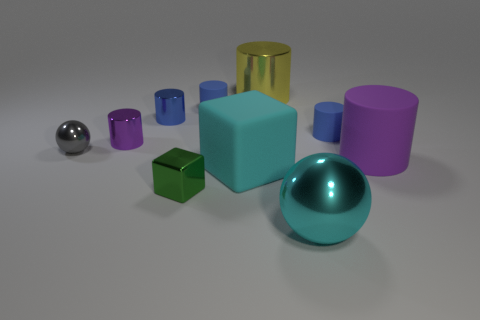Subtract all cyan cubes. How many blue cylinders are left? 3 Subtract all large metallic cylinders. How many cylinders are left? 5 Subtract all yellow cylinders. How many cylinders are left? 5 Subtract all gray cylinders. Subtract all gray balls. How many cylinders are left? 6 Subtract all spheres. How many objects are left? 8 Subtract 0 green cylinders. How many objects are left? 10 Subtract all yellow metal objects. Subtract all tiny gray things. How many objects are left? 8 Add 5 gray metallic spheres. How many gray metallic spheres are left? 6 Add 1 gray metallic balls. How many gray metallic balls exist? 2 